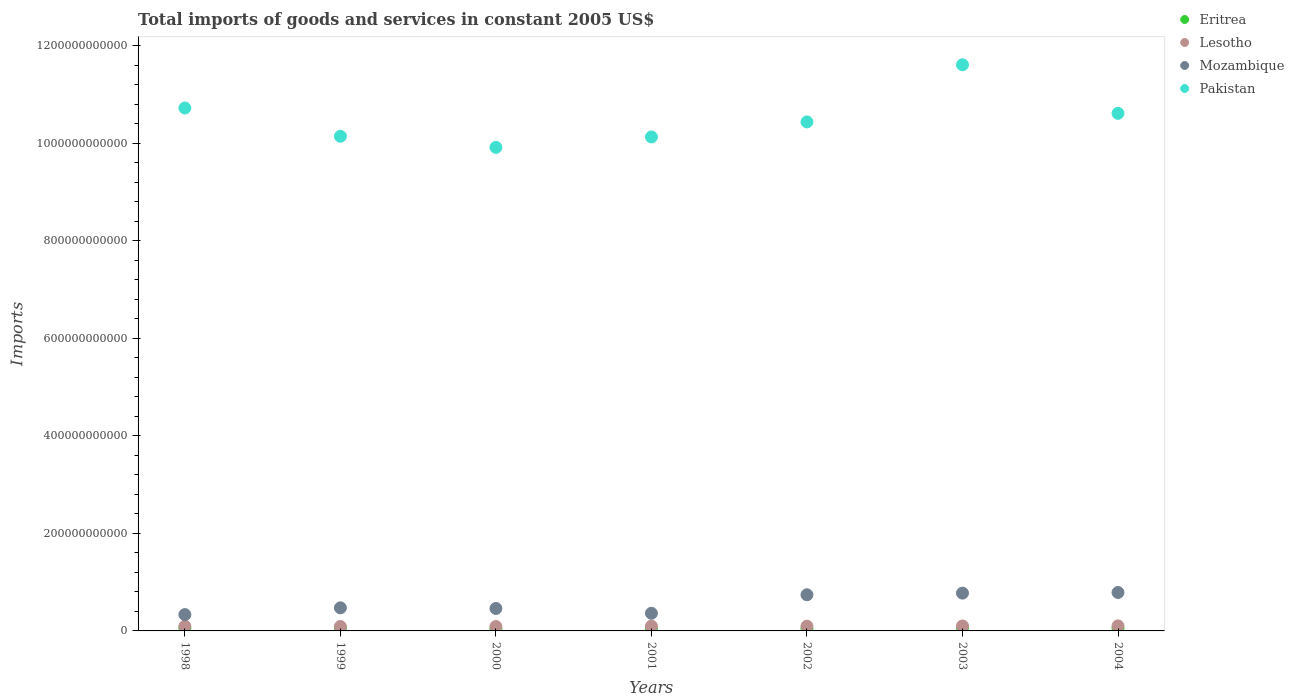Is the number of dotlines equal to the number of legend labels?
Your answer should be compact. Yes. What is the total imports of goods and services in Lesotho in 2004?
Your answer should be very brief. 1.03e+1. Across all years, what is the maximum total imports of goods and services in Eritrea?
Provide a succinct answer. 5.84e+09. Across all years, what is the minimum total imports of goods and services in Eritrea?
Your answer should be very brief. 3.96e+09. What is the total total imports of goods and services in Pakistan in the graph?
Ensure brevity in your answer.  7.36e+12. What is the difference between the total imports of goods and services in Lesotho in 2001 and that in 2002?
Give a very brief answer. 6.00e+07. What is the difference between the total imports of goods and services in Lesotho in 2003 and the total imports of goods and services in Pakistan in 1999?
Provide a short and direct response. -1.00e+12. What is the average total imports of goods and services in Eritrea per year?
Provide a succinct answer. 5.07e+09. In the year 2004, what is the difference between the total imports of goods and services in Eritrea and total imports of goods and services in Lesotho?
Provide a succinct answer. -4.99e+09. What is the ratio of the total imports of goods and services in Mozambique in 2000 to that in 2001?
Your answer should be compact. 1.27. Is the total imports of goods and services in Eritrea in 2002 less than that in 2003?
Ensure brevity in your answer.  Yes. What is the difference between the highest and the second highest total imports of goods and services in Lesotho?
Your response must be concise. 1.52e+08. What is the difference between the highest and the lowest total imports of goods and services in Pakistan?
Give a very brief answer. 1.69e+11. In how many years, is the total imports of goods and services in Lesotho greater than the average total imports of goods and services in Lesotho taken over all years?
Offer a terse response. 4. Is the sum of the total imports of goods and services in Eritrea in 1998 and 2000 greater than the maximum total imports of goods and services in Lesotho across all years?
Ensure brevity in your answer.  No. Is it the case that in every year, the sum of the total imports of goods and services in Mozambique and total imports of goods and services in Pakistan  is greater than the sum of total imports of goods and services in Lesotho and total imports of goods and services in Eritrea?
Your answer should be compact. Yes. Does the total imports of goods and services in Mozambique monotonically increase over the years?
Keep it short and to the point. No. Is the total imports of goods and services in Pakistan strictly greater than the total imports of goods and services in Eritrea over the years?
Keep it short and to the point. Yes. Is the total imports of goods and services in Pakistan strictly less than the total imports of goods and services in Lesotho over the years?
Make the answer very short. No. What is the difference between two consecutive major ticks on the Y-axis?
Offer a very short reply. 2.00e+11. Are the values on the major ticks of Y-axis written in scientific E-notation?
Your response must be concise. No. Where does the legend appear in the graph?
Provide a succinct answer. Top right. How are the legend labels stacked?
Give a very brief answer. Vertical. What is the title of the graph?
Ensure brevity in your answer.  Total imports of goods and services in constant 2005 US$. What is the label or title of the Y-axis?
Provide a short and direct response. Imports. What is the Imports of Eritrea in 1998?
Ensure brevity in your answer.  5.74e+09. What is the Imports in Lesotho in 1998?
Your answer should be very brief. 9.67e+09. What is the Imports of Mozambique in 1998?
Offer a very short reply. 3.35e+1. What is the Imports of Pakistan in 1998?
Offer a terse response. 1.07e+12. What is the Imports of Eritrea in 1999?
Your answer should be very brief. 5.84e+09. What is the Imports in Lesotho in 1999?
Give a very brief answer. 9.06e+09. What is the Imports of Mozambique in 1999?
Your response must be concise. 4.74e+1. What is the Imports of Pakistan in 1999?
Your response must be concise. 1.01e+12. What is the Imports of Eritrea in 2000?
Make the answer very short. 3.96e+09. What is the Imports of Lesotho in 2000?
Your answer should be very brief. 9.07e+09. What is the Imports in Mozambique in 2000?
Ensure brevity in your answer.  4.60e+1. What is the Imports of Pakistan in 2000?
Your answer should be compact. 9.92e+11. What is the Imports in Eritrea in 2001?
Offer a terse response. 4.54e+09. What is the Imports of Lesotho in 2001?
Give a very brief answer. 9.80e+09. What is the Imports in Mozambique in 2001?
Offer a terse response. 3.62e+1. What is the Imports in Pakistan in 2001?
Your answer should be compact. 1.01e+12. What is the Imports of Eritrea in 2002?
Make the answer very short. 4.62e+09. What is the Imports of Lesotho in 2002?
Your answer should be very brief. 9.74e+09. What is the Imports in Mozambique in 2002?
Make the answer very short. 7.41e+1. What is the Imports in Pakistan in 2002?
Make the answer very short. 1.04e+12. What is the Imports in Eritrea in 2003?
Offer a very short reply. 5.43e+09. What is the Imports of Lesotho in 2003?
Keep it short and to the point. 1.02e+1. What is the Imports in Mozambique in 2003?
Ensure brevity in your answer.  7.75e+1. What is the Imports in Pakistan in 2003?
Give a very brief answer. 1.16e+12. What is the Imports in Eritrea in 2004?
Ensure brevity in your answer.  5.35e+09. What is the Imports of Lesotho in 2004?
Ensure brevity in your answer.  1.03e+1. What is the Imports of Mozambique in 2004?
Provide a short and direct response. 7.88e+1. What is the Imports of Pakistan in 2004?
Offer a terse response. 1.06e+12. Across all years, what is the maximum Imports in Eritrea?
Keep it short and to the point. 5.84e+09. Across all years, what is the maximum Imports of Lesotho?
Provide a short and direct response. 1.03e+1. Across all years, what is the maximum Imports of Mozambique?
Provide a succinct answer. 7.88e+1. Across all years, what is the maximum Imports of Pakistan?
Provide a succinct answer. 1.16e+12. Across all years, what is the minimum Imports in Eritrea?
Ensure brevity in your answer.  3.96e+09. Across all years, what is the minimum Imports of Lesotho?
Offer a very short reply. 9.06e+09. Across all years, what is the minimum Imports in Mozambique?
Your answer should be compact. 3.35e+1. Across all years, what is the minimum Imports in Pakistan?
Offer a very short reply. 9.92e+11. What is the total Imports of Eritrea in the graph?
Provide a succinct answer. 3.55e+1. What is the total Imports of Lesotho in the graph?
Offer a terse response. 6.79e+1. What is the total Imports of Mozambique in the graph?
Make the answer very short. 3.94e+11. What is the total Imports in Pakistan in the graph?
Keep it short and to the point. 7.36e+12. What is the difference between the Imports of Eritrea in 1998 and that in 1999?
Your response must be concise. -1.03e+08. What is the difference between the Imports in Lesotho in 1998 and that in 1999?
Provide a short and direct response. 6.06e+08. What is the difference between the Imports of Mozambique in 1998 and that in 1999?
Keep it short and to the point. -1.39e+1. What is the difference between the Imports in Pakistan in 1998 and that in 1999?
Provide a short and direct response. 5.79e+1. What is the difference between the Imports of Eritrea in 1998 and that in 2000?
Make the answer very short. 1.78e+09. What is the difference between the Imports of Lesotho in 1998 and that in 2000?
Keep it short and to the point. 6.01e+08. What is the difference between the Imports in Mozambique in 1998 and that in 2000?
Provide a short and direct response. -1.26e+1. What is the difference between the Imports in Pakistan in 1998 and that in 2000?
Ensure brevity in your answer.  8.08e+1. What is the difference between the Imports in Eritrea in 1998 and that in 2001?
Provide a succinct answer. 1.21e+09. What is the difference between the Imports of Lesotho in 1998 and that in 2001?
Give a very brief answer. -1.25e+08. What is the difference between the Imports of Mozambique in 1998 and that in 2001?
Your response must be concise. -2.75e+09. What is the difference between the Imports of Pakistan in 1998 and that in 2001?
Your answer should be very brief. 5.93e+1. What is the difference between the Imports of Eritrea in 1998 and that in 2002?
Offer a terse response. 1.12e+09. What is the difference between the Imports of Lesotho in 1998 and that in 2002?
Your answer should be very brief. -6.50e+07. What is the difference between the Imports in Mozambique in 1998 and that in 2002?
Keep it short and to the point. -4.07e+1. What is the difference between the Imports of Pakistan in 1998 and that in 2002?
Give a very brief answer. 2.85e+1. What is the difference between the Imports of Eritrea in 1998 and that in 2003?
Ensure brevity in your answer.  3.11e+08. What is the difference between the Imports in Lesotho in 1998 and that in 2003?
Provide a short and direct response. -5.24e+08. What is the difference between the Imports in Mozambique in 1998 and that in 2003?
Your response must be concise. -4.41e+1. What is the difference between the Imports of Pakistan in 1998 and that in 2003?
Offer a terse response. -8.87e+1. What is the difference between the Imports of Eritrea in 1998 and that in 2004?
Your answer should be very brief. 3.86e+08. What is the difference between the Imports in Lesotho in 1998 and that in 2004?
Your response must be concise. -6.76e+08. What is the difference between the Imports in Mozambique in 1998 and that in 2004?
Offer a very short reply. -4.54e+1. What is the difference between the Imports in Pakistan in 1998 and that in 2004?
Make the answer very short. 1.09e+1. What is the difference between the Imports in Eritrea in 1999 and that in 2000?
Your response must be concise. 1.89e+09. What is the difference between the Imports in Lesotho in 1999 and that in 2000?
Your response must be concise. -4.86e+06. What is the difference between the Imports in Mozambique in 1999 and that in 2000?
Your answer should be compact. 1.32e+09. What is the difference between the Imports of Pakistan in 1999 and that in 2000?
Give a very brief answer. 2.28e+1. What is the difference between the Imports of Eritrea in 1999 and that in 2001?
Offer a terse response. 1.31e+09. What is the difference between the Imports of Lesotho in 1999 and that in 2001?
Keep it short and to the point. -7.31e+08. What is the difference between the Imports of Mozambique in 1999 and that in 2001?
Your response must be concise. 1.11e+1. What is the difference between the Imports in Pakistan in 1999 and that in 2001?
Ensure brevity in your answer.  1.41e+09. What is the difference between the Imports in Eritrea in 1999 and that in 2002?
Give a very brief answer. 1.22e+09. What is the difference between the Imports of Lesotho in 1999 and that in 2002?
Your answer should be compact. -6.71e+08. What is the difference between the Imports of Mozambique in 1999 and that in 2002?
Make the answer very short. -2.68e+1. What is the difference between the Imports of Pakistan in 1999 and that in 2002?
Offer a very short reply. -2.94e+1. What is the difference between the Imports in Eritrea in 1999 and that in 2003?
Offer a terse response. 4.14e+08. What is the difference between the Imports of Lesotho in 1999 and that in 2003?
Ensure brevity in your answer.  -1.13e+09. What is the difference between the Imports of Mozambique in 1999 and that in 2003?
Keep it short and to the point. -3.02e+1. What is the difference between the Imports in Pakistan in 1999 and that in 2003?
Give a very brief answer. -1.47e+11. What is the difference between the Imports in Eritrea in 1999 and that in 2004?
Keep it short and to the point. 4.90e+08. What is the difference between the Imports in Lesotho in 1999 and that in 2004?
Provide a short and direct response. -1.28e+09. What is the difference between the Imports in Mozambique in 1999 and that in 2004?
Your answer should be compact. -3.15e+1. What is the difference between the Imports of Pakistan in 1999 and that in 2004?
Your answer should be compact. -4.70e+1. What is the difference between the Imports in Eritrea in 2000 and that in 2001?
Your answer should be compact. -5.78e+08. What is the difference between the Imports in Lesotho in 2000 and that in 2001?
Keep it short and to the point. -7.26e+08. What is the difference between the Imports of Mozambique in 2000 and that in 2001?
Give a very brief answer. 9.81e+09. What is the difference between the Imports of Pakistan in 2000 and that in 2001?
Your answer should be very brief. -2.14e+1. What is the difference between the Imports of Eritrea in 2000 and that in 2002?
Provide a succinct answer. -6.64e+08. What is the difference between the Imports of Lesotho in 2000 and that in 2002?
Offer a very short reply. -6.66e+08. What is the difference between the Imports in Mozambique in 2000 and that in 2002?
Ensure brevity in your answer.  -2.81e+1. What is the difference between the Imports in Pakistan in 2000 and that in 2002?
Give a very brief answer. -5.23e+1. What is the difference between the Imports of Eritrea in 2000 and that in 2003?
Your answer should be compact. -1.47e+09. What is the difference between the Imports in Lesotho in 2000 and that in 2003?
Provide a succinct answer. -1.13e+09. What is the difference between the Imports in Mozambique in 2000 and that in 2003?
Keep it short and to the point. -3.15e+1. What is the difference between the Imports in Pakistan in 2000 and that in 2003?
Keep it short and to the point. -1.69e+11. What is the difference between the Imports in Eritrea in 2000 and that in 2004?
Your answer should be very brief. -1.40e+09. What is the difference between the Imports of Lesotho in 2000 and that in 2004?
Your response must be concise. -1.28e+09. What is the difference between the Imports of Mozambique in 2000 and that in 2004?
Provide a short and direct response. -3.28e+1. What is the difference between the Imports of Pakistan in 2000 and that in 2004?
Offer a very short reply. -6.98e+1. What is the difference between the Imports in Eritrea in 2001 and that in 2002?
Your response must be concise. -8.56e+07. What is the difference between the Imports of Lesotho in 2001 and that in 2002?
Your response must be concise. 6.00e+07. What is the difference between the Imports of Mozambique in 2001 and that in 2002?
Provide a short and direct response. -3.79e+1. What is the difference between the Imports of Pakistan in 2001 and that in 2002?
Offer a very short reply. -3.08e+1. What is the difference between the Imports of Eritrea in 2001 and that in 2003?
Your response must be concise. -8.95e+08. What is the difference between the Imports of Lesotho in 2001 and that in 2003?
Provide a short and direct response. -3.99e+08. What is the difference between the Imports of Mozambique in 2001 and that in 2003?
Ensure brevity in your answer.  -4.13e+1. What is the difference between the Imports of Pakistan in 2001 and that in 2003?
Provide a short and direct response. -1.48e+11. What is the difference between the Imports of Eritrea in 2001 and that in 2004?
Ensure brevity in your answer.  -8.19e+08. What is the difference between the Imports of Lesotho in 2001 and that in 2004?
Give a very brief answer. -5.51e+08. What is the difference between the Imports in Mozambique in 2001 and that in 2004?
Your answer should be compact. -4.26e+1. What is the difference between the Imports of Pakistan in 2001 and that in 2004?
Provide a short and direct response. -4.84e+1. What is the difference between the Imports of Eritrea in 2002 and that in 2003?
Make the answer very short. -8.09e+08. What is the difference between the Imports of Lesotho in 2002 and that in 2003?
Provide a short and direct response. -4.59e+08. What is the difference between the Imports in Mozambique in 2002 and that in 2003?
Offer a terse response. -3.41e+09. What is the difference between the Imports of Pakistan in 2002 and that in 2003?
Offer a terse response. -1.17e+11. What is the difference between the Imports of Eritrea in 2002 and that in 2004?
Your answer should be very brief. -7.33e+08. What is the difference between the Imports of Lesotho in 2002 and that in 2004?
Keep it short and to the point. -6.11e+08. What is the difference between the Imports of Mozambique in 2002 and that in 2004?
Your response must be concise. -4.72e+09. What is the difference between the Imports in Pakistan in 2002 and that in 2004?
Ensure brevity in your answer.  -1.76e+1. What is the difference between the Imports in Eritrea in 2003 and that in 2004?
Keep it short and to the point. 7.59e+07. What is the difference between the Imports of Lesotho in 2003 and that in 2004?
Make the answer very short. -1.52e+08. What is the difference between the Imports of Mozambique in 2003 and that in 2004?
Provide a short and direct response. -1.30e+09. What is the difference between the Imports in Pakistan in 2003 and that in 2004?
Offer a very short reply. 9.96e+1. What is the difference between the Imports of Eritrea in 1998 and the Imports of Lesotho in 1999?
Keep it short and to the point. -3.32e+09. What is the difference between the Imports in Eritrea in 1998 and the Imports in Mozambique in 1999?
Provide a succinct answer. -4.16e+1. What is the difference between the Imports in Eritrea in 1998 and the Imports in Pakistan in 1999?
Ensure brevity in your answer.  -1.01e+12. What is the difference between the Imports in Lesotho in 1998 and the Imports in Mozambique in 1999?
Make the answer very short. -3.77e+1. What is the difference between the Imports in Lesotho in 1998 and the Imports in Pakistan in 1999?
Provide a succinct answer. -1.01e+12. What is the difference between the Imports in Mozambique in 1998 and the Imports in Pakistan in 1999?
Ensure brevity in your answer.  -9.81e+11. What is the difference between the Imports of Eritrea in 1998 and the Imports of Lesotho in 2000?
Your response must be concise. -3.33e+09. What is the difference between the Imports in Eritrea in 1998 and the Imports in Mozambique in 2000?
Make the answer very short. -4.03e+1. What is the difference between the Imports in Eritrea in 1998 and the Imports in Pakistan in 2000?
Ensure brevity in your answer.  -9.86e+11. What is the difference between the Imports in Lesotho in 1998 and the Imports in Mozambique in 2000?
Your answer should be compact. -3.64e+1. What is the difference between the Imports of Lesotho in 1998 and the Imports of Pakistan in 2000?
Your answer should be very brief. -9.82e+11. What is the difference between the Imports of Mozambique in 1998 and the Imports of Pakistan in 2000?
Your answer should be compact. -9.58e+11. What is the difference between the Imports in Eritrea in 1998 and the Imports in Lesotho in 2001?
Give a very brief answer. -4.05e+09. What is the difference between the Imports of Eritrea in 1998 and the Imports of Mozambique in 2001?
Ensure brevity in your answer.  -3.05e+1. What is the difference between the Imports in Eritrea in 1998 and the Imports in Pakistan in 2001?
Keep it short and to the point. -1.01e+12. What is the difference between the Imports of Lesotho in 1998 and the Imports of Mozambique in 2001?
Ensure brevity in your answer.  -2.66e+1. What is the difference between the Imports of Lesotho in 1998 and the Imports of Pakistan in 2001?
Your response must be concise. -1.00e+12. What is the difference between the Imports of Mozambique in 1998 and the Imports of Pakistan in 2001?
Provide a short and direct response. -9.80e+11. What is the difference between the Imports of Eritrea in 1998 and the Imports of Lesotho in 2002?
Offer a very short reply. -3.99e+09. What is the difference between the Imports of Eritrea in 1998 and the Imports of Mozambique in 2002?
Your response must be concise. -6.84e+1. What is the difference between the Imports in Eritrea in 1998 and the Imports in Pakistan in 2002?
Give a very brief answer. -1.04e+12. What is the difference between the Imports in Lesotho in 1998 and the Imports in Mozambique in 2002?
Offer a terse response. -6.45e+1. What is the difference between the Imports in Lesotho in 1998 and the Imports in Pakistan in 2002?
Offer a terse response. -1.03e+12. What is the difference between the Imports of Mozambique in 1998 and the Imports of Pakistan in 2002?
Ensure brevity in your answer.  -1.01e+12. What is the difference between the Imports in Eritrea in 1998 and the Imports in Lesotho in 2003?
Give a very brief answer. -4.45e+09. What is the difference between the Imports of Eritrea in 1998 and the Imports of Mozambique in 2003?
Your response must be concise. -7.18e+1. What is the difference between the Imports in Eritrea in 1998 and the Imports in Pakistan in 2003?
Give a very brief answer. -1.16e+12. What is the difference between the Imports in Lesotho in 1998 and the Imports in Mozambique in 2003?
Offer a terse response. -6.79e+1. What is the difference between the Imports in Lesotho in 1998 and the Imports in Pakistan in 2003?
Keep it short and to the point. -1.15e+12. What is the difference between the Imports of Mozambique in 1998 and the Imports of Pakistan in 2003?
Your answer should be compact. -1.13e+12. What is the difference between the Imports of Eritrea in 1998 and the Imports of Lesotho in 2004?
Provide a short and direct response. -4.61e+09. What is the difference between the Imports in Eritrea in 1998 and the Imports in Mozambique in 2004?
Your answer should be compact. -7.31e+1. What is the difference between the Imports in Eritrea in 1998 and the Imports in Pakistan in 2004?
Ensure brevity in your answer.  -1.06e+12. What is the difference between the Imports of Lesotho in 1998 and the Imports of Mozambique in 2004?
Keep it short and to the point. -6.92e+1. What is the difference between the Imports in Lesotho in 1998 and the Imports in Pakistan in 2004?
Your answer should be compact. -1.05e+12. What is the difference between the Imports of Mozambique in 1998 and the Imports of Pakistan in 2004?
Give a very brief answer. -1.03e+12. What is the difference between the Imports in Eritrea in 1999 and the Imports in Lesotho in 2000?
Provide a short and direct response. -3.23e+09. What is the difference between the Imports in Eritrea in 1999 and the Imports in Mozambique in 2000?
Ensure brevity in your answer.  -4.02e+1. What is the difference between the Imports in Eritrea in 1999 and the Imports in Pakistan in 2000?
Provide a succinct answer. -9.86e+11. What is the difference between the Imports of Lesotho in 1999 and the Imports of Mozambique in 2000?
Offer a very short reply. -3.70e+1. What is the difference between the Imports in Lesotho in 1999 and the Imports in Pakistan in 2000?
Your answer should be compact. -9.83e+11. What is the difference between the Imports in Mozambique in 1999 and the Imports in Pakistan in 2000?
Provide a short and direct response. -9.45e+11. What is the difference between the Imports of Eritrea in 1999 and the Imports of Lesotho in 2001?
Provide a short and direct response. -3.95e+09. What is the difference between the Imports in Eritrea in 1999 and the Imports in Mozambique in 2001?
Your answer should be very brief. -3.04e+1. What is the difference between the Imports of Eritrea in 1999 and the Imports of Pakistan in 2001?
Your response must be concise. -1.01e+12. What is the difference between the Imports of Lesotho in 1999 and the Imports of Mozambique in 2001?
Your response must be concise. -2.72e+1. What is the difference between the Imports in Lesotho in 1999 and the Imports in Pakistan in 2001?
Ensure brevity in your answer.  -1.00e+12. What is the difference between the Imports of Mozambique in 1999 and the Imports of Pakistan in 2001?
Ensure brevity in your answer.  -9.66e+11. What is the difference between the Imports of Eritrea in 1999 and the Imports of Lesotho in 2002?
Your answer should be compact. -3.89e+09. What is the difference between the Imports of Eritrea in 1999 and the Imports of Mozambique in 2002?
Your answer should be compact. -6.83e+1. What is the difference between the Imports of Eritrea in 1999 and the Imports of Pakistan in 2002?
Your answer should be very brief. -1.04e+12. What is the difference between the Imports in Lesotho in 1999 and the Imports in Mozambique in 2002?
Offer a very short reply. -6.51e+1. What is the difference between the Imports of Lesotho in 1999 and the Imports of Pakistan in 2002?
Keep it short and to the point. -1.04e+12. What is the difference between the Imports in Mozambique in 1999 and the Imports in Pakistan in 2002?
Provide a short and direct response. -9.97e+11. What is the difference between the Imports in Eritrea in 1999 and the Imports in Lesotho in 2003?
Provide a short and direct response. -4.35e+09. What is the difference between the Imports in Eritrea in 1999 and the Imports in Mozambique in 2003?
Your response must be concise. -7.17e+1. What is the difference between the Imports in Eritrea in 1999 and the Imports in Pakistan in 2003?
Ensure brevity in your answer.  -1.16e+12. What is the difference between the Imports of Lesotho in 1999 and the Imports of Mozambique in 2003?
Your answer should be very brief. -6.85e+1. What is the difference between the Imports of Lesotho in 1999 and the Imports of Pakistan in 2003?
Ensure brevity in your answer.  -1.15e+12. What is the difference between the Imports of Mozambique in 1999 and the Imports of Pakistan in 2003?
Make the answer very short. -1.11e+12. What is the difference between the Imports in Eritrea in 1999 and the Imports in Lesotho in 2004?
Ensure brevity in your answer.  -4.50e+09. What is the difference between the Imports of Eritrea in 1999 and the Imports of Mozambique in 2004?
Your response must be concise. -7.30e+1. What is the difference between the Imports in Eritrea in 1999 and the Imports in Pakistan in 2004?
Provide a succinct answer. -1.06e+12. What is the difference between the Imports in Lesotho in 1999 and the Imports in Mozambique in 2004?
Provide a succinct answer. -6.98e+1. What is the difference between the Imports in Lesotho in 1999 and the Imports in Pakistan in 2004?
Your answer should be very brief. -1.05e+12. What is the difference between the Imports in Mozambique in 1999 and the Imports in Pakistan in 2004?
Make the answer very short. -1.01e+12. What is the difference between the Imports in Eritrea in 2000 and the Imports in Lesotho in 2001?
Offer a very short reply. -5.84e+09. What is the difference between the Imports in Eritrea in 2000 and the Imports in Mozambique in 2001?
Your response must be concise. -3.23e+1. What is the difference between the Imports in Eritrea in 2000 and the Imports in Pakistan in 2001?
Offer a very short reply. -1.01e+12. What is the difference between the Imports in Lesotho in 2000 and the Imports in Mozambique in 2001?
Provide a succinct answer. -2.72e+1. What is the difference between the Imports in Lesotho in 2000 and the Imports in Pakistan in 2001?
Provide a short and direct response. -1.00e+12. What is the difference between the Imports of Mozambique in 2000 and the Imports of Pakistan in 2001?
Make the answer very short. -9.67e+11. What is the difference between the Imports of Eritrea in 2000 and the Imports of Lesotho in 2002?
Make the answer very short. -5.78e+09. What is the difference between the Imports of Eritrea in 2000 and the Imports of Mozambique in 2002?
Offer a very short reply. -7.02e+1. What is the difference between the Imports in Eritrea in 2000 and the Imports in Pakistan in 2002?
Offer a terse response. -1.04e+12. What is the difference between the Imports of Lesotho in 2000 and the Imports of Mozambique in 2002?
Provide a succinct answer. -6.51e+1. What is the difference between the Imports in Lesotho in 2000 and the Imports in Pakistan in 2002?
Provide a succinct answer. -1.04e+12. What is the difference between the Imports of Mozambique in 2000 and the Imports of Pakistan in 2002?
Your response must be concise. -9.98e+11. What is the difference between the Imports in Eritrea in 2000 and the Imports in Lesotho in 2003?
Keep it short and to the point. -6.24e+09. What is the difference between the Imports in Eritrea in 2000 and the Imports in Mozambique in 2003?
Your answer should be compact. -7.36e+1. What is the difference between the Imports of Eritrea in 2000 and the Imports of Pakistan in 2003?
Give a very brief answer. -1.16e+12. What is the difference between the Imports of Lesotho in 2000 and the Imports of Mozambique in 2003?
Your answer should be compact. -6.85e+1. What is the difference between the Imports of Lesotho in 2000 and the Imports of Pakistan in 2003?
Your answer should be compact. -1.15e+12. What is the difference between the Imports of Mozambique in 2000 and the Imports of Pakistan in 2003?
Offer a terse response. -1.12e+12. What is the difference between the Imports in Eritrea in 2000 and the Imports in Lesotho in 2004?
Make the answer very short. -6.39e+09. What is the difference between the Imports in Eritrea in 2000 and the Imports in Mozambique in 2004?
Make the answer very short. -7.49e+1. What is the difference between the Imports in Eritrea in 2000 and the Imports in Pakistan in 2004?
Your answer should be very brief. -1.06e+12. What is the difference between the Imports in Lesotho in 2000 and the Imports in Mozambique in 2004?
Your answer should be very brief. -6.98e+1. What is the difference between the Imports in Lesotho in 2000 and the Imports in Pakistan in 2004?
Make the answer very short. -1.05e+12. What is the difference between the Imports in Mozambique in 2000 and the Imports in Pakistan in 2004?
Your answer should be compact. -1.02e+12. What is the difference between the Imports of Eritrea in 2001 and the Imports of Lesotho in 2002?
Offer a very short reply. -5.20e+09. What is the difference between the Imports of Eritrea in 2001 and the Imports of Mozambique in 2002?
Make the answer very short. -6.96e+1. What is the difference between the Imports of Eritrea in 2001 and the Imports of Pakistan in 2002?
Make the answer very short. -1.04e+12. What is the difference between the Imports in Lesotho in 2001 and the Imports in Mozambique in 2002?
Your answer should be very brief. -6.43e+1. What is the difference between the Imports in Lesotho in 2001 and the Imports in Pakistan in 2002?
Give a very brief answer. -1.03e+12. What is the difference between the Imports in Mozambique in 2001 and the Imports in Pakistan in 2002?
Provide a short and direct response. -1.01e+12. What is the difference between the Imports in Eritrea in 2001 and the Imports in Lesotho in 2003?
Your answer should be compact. -5.66e+09. What is the difference between the Imports in Eritrea in 2001 and the Imports in Mozambique in 2003?
Offer a very short reply. -7.30e+1. What is the difference between the Imports of Eritrea in 2001 and the Imports of Pakistan in 2003?
Your response must be concise. -1.16e+12. What is the difference between the Imports in Lesotho in 2001 and the Imports in Mozambique in 2003?
Offer a terse response. -6.77e+1. What is the difference between the Imports of Lesotho in 2001 and the Imports of Pakistan in 2003?
Offer a terse response. -1.15e+12. What is the difference between the Imports of Mozambique in 2001 and the Imports of Pakistan in 2003?
Keep it short and to the point. -1.13e+12. What is the difference between the Imports of Eritrea in 2001 and the Imports of Lesotho in 2004?
Offer a very short reply. -5.81e+09. What is the difference between the Imports in Eritrea in 2001 and the Imports in Mozambique in 2004?
Your answer should be compact. -7.43e+1. What is the difference between the Imports in Eritrea in 2001 and the Imports in Pakistan in 2004?
Your response must be concise. -1.06e+12. What is the difference between the Imports in Lesotho in 2001 and the Imports in Mozambique in 2004?
Give a very brief answer. -6.91e+1. What is the difference between the Imports of Lesotho in 2001 and the Imports of Pakistan in 2004?
Your answer should be very brief. -1.05e+12. What is the difference between the Imports of Mozambique in 2001 and the Imports of Pakistan in 2004?
Provide a succinct answer. -1.03e+12. What is the difference between the Imports in Eritrea in 2002 and the Imports in Lesotho in 2003?
Give a very brief answer. -5.57e+09. What is the difference between the Imports of Eritrea in 2002 and the Imports of Mozambique in 2003?
Provide a succinct answer. -7.29e+1. What is the difference between the Imports in Eritrea in 2002 and the Imports in Pakistan in 2003?
Offer a very short reply. -1.16e+12. What is the difference between the Imports of Lesotho in 2002 and the Imports of Mozambique in 2003?
Provide a succinct answer. -6.78e+1. What is the difference between the Imports of Lesotho in 2002 and the Imports of Pakistan in 2003?
Offer a very short reply. -1.15e+12. What is the difference between the Imports of Mozambique in 2002 and the Imports of Pakistan in 2003?
Provide a short and direct response. -1.09e+12. What is the difference between the Imports in Eritrea in 2002 and the Imports in Lesotho in 2004?
Your answer should be compact. -5.73e+09. What is the difference between the Imports in Eritrea in 2002 and the Imports in Mozambique in 2004?
Offer a very short reply. -7.42e+1. What is the difference between the Imports of Eritrea in 2002 and the Imports of Pakistan in 2004?
Offer a terse response. -1.06e+12. What is the difference between the Imports of Lesotho in 2002 and the Imports of Mozambique in 2004?
Ensure brevity in your answer.  -6.91e+1. What is the difference between the Imports of Lesotho in 2002 and the Imports of Pakistan in 2004?
Provide a succinct answer. -1.05e+12. What is the difference between the Imports of Mozambique in 2002 and the Imports of Pakistan in 2004?
Your response must be concise. -9.88e+11. What is the difference between the Imports in Eritrea in 2003 and the Imports in Lesotho in 2004?
Make the answer very short. -4.92e+09. What is the difference between the Imports in Eritrea in 2003 and the Imports in Mozambique in 2004?
Provide a succinct answer. -7.34e+1. What is the difference between the Imports of Eritrea in 2003 and the Imports of Pakistan in 2004?
Your response must be concise. -1.06e+12. What is the difference between the Imports in Lesotho in 2003 and the Imports in Mozambique in 2004?
Make the answer very short. -6.87e+1. What is the difference between the Imports in Lesotho in 2003 and the Imports in Pakistan in 2004?
Give a very brief answer. -1.05e+12. What is the difference between the Imports of Mozambique in 2003 and the Imports of Pakistan in 2004?
Offer a very short reply. -9.84e+11. What is the average Imports in Eritrea per year?
Provide a short and direct response. 5.07e+09. What is the average Imports of Lesotho per year?
Your response must be concise. 9.70e+09. What is the average Imports of Mozambique per year?
Your response must be concise. 5.62e+1. What is the average Imports of Pakistan per year?
Your response must be concise. 1.05e+12. In the year 1998, what is the difference between the Imports in Eritrea and Imports in Lesotho?
Keep it short and to the point. -3.93e+09. In the year 1998, what is the difference between the Imports of Eritrea and Imports of Mozambique?
Your answer should be very brief. -2.77e+1. In the year 1998, what is the difference between the Imports of Eritrea and Imports of Pakistan?
Offer a terse response. -1.07e+12. In the year 1998, what is the difference between the Imports of Lesotho and Imports of Mozambique?
Offer a terse response. -2.38e+1. In the year 1998, what is the difference between the Imports in Lesotho and Imports in Pakistan?
Offer a terse response. -1.06e+12. In the year 1998, what is the difference between the Imports of Mozambique and Imports of Pakistan?
Offer a very short reply. -1.04e+12. In the year 1999, what is the difference between the Imports in Eritrea and Imports in Lesotho?
Give a very brief answer. -3.22e+09. In the year 1999, what is the difference between the Imports of Eritrea and Imports of Mozambique?
Provide a short and direct response. -4.15e+1. In the year 1999, what is the difference between the Imports of Eritrea and Imports of Pakistan?
Make the answer very short. -1.01e+12. In the year 1999, what is the difference between the Imports in Lesotho and Imports in Mozambique?
Offer a very short reply. -3.83e+1. In the year 1999, what is the difference between the Imports in Lesotho and Imports in Pakistan?
Ensure brevity in your answer.  -1.01e+12. In the year 1999, what is the difference between the Imports of Mozambique and Imports of Pakistan?
Your response must be concise. -9.67e+11. In the year 2000, what is the difference between the Imports in Eritrea and Imports in Lesotho?
Make the answer very short. -5.11e+09. In the year 2000, what is the difference between the Imports of Eritrea and Imports of Mozambique?
Keep it short and to the point. -4.21e+1. In the year 2000, what is the difference between the Imports in Eritrea and Imports in Pakistan?
Make the answer very short. -9.88e+11. In the year 2000, what is the difference between the Imports of Lesotho and Imports of Mozambique?
Offer a terse response. -3.70e+1. In the year 2000, what is the difference between the Imports in Lesotho and Imports in Pakistan?
Your answer should be very brief. -9.83e+11. In the year 2000, what is the difference between the Imports of Mozambique and Imports of Pakistan?
Provide a short and direct response. -9.46e+11. In the year 2001, what is the difference between the Imports of Eritrea and Imports of Lesotho?
Your answer should be compact. -5.26e+09. In the year 2001, what is the difference between the Imports of Eritrea and Imports of Mozambique?
Make the answer very short. -3.17e+1. In the year 2001, what is the difference between the Imports of Eritrea and Imports of Pakistan?
Ensure brevity in your answer.  -1.01e+12. In the year 2001, what is the difference between the Imports of Lesotho and Imports of Mozambique?
Make the answer very short. -2.64e+1. In the year 2001, what is the difference between the Imports in Lesotho and Imports in Pakistan?
Provide a short and direct response. -1.00e+12. In the year 2001, what is the difference between the Imports of Mozambique and Imports of Pakistan?
Provide a short and direct response. -9.77e+11. In the year 2002, what is the difference between the Imports of Eritrea and Imports of Lesotho?
Your answer should be compact. -5.11e+09. In the year 2002, what is the difference between the Imports of Eritrea and Imports of Mozambique?
Make the answer very short. -6.95e+1. In the year 2002, what is the difference between the Imports in Eritrea and Imports in Pakistan?
Offer a very short reply. -1.04e+12. In the year 2002, what is the difference between the Imports in Lesotho and Imports in Mozambique?
Keep it short and to the point. -6.44e+1. In the year 2002, what is the difference between the Imports in Lesotho and Imports in Pakistan?
Provide a short and direct response. -1.03e+12. In the year 2002, what is the difference between the Imports of Mozambique and Imports of Pakistan?
Keep it short and to the point. -9.70e+11. In the year 2003, what is the difference between the Imports of Eritrea and Imports of Lesotho?
Your response must be concise. -4.76e+09. In the year 2003, what is the difference between the Imports of Eritrea and Imports of Mozambique?
Make the answer very short. -7.21e+1. In the year 2003, what is the difference between the Imports of Eritrea and Imports of Pakistan?
Offer a very short reply. -1.16e+12. In the year 2003, what is the difference between the Imports of Lesotho and Imports of Mozambique?
Provide a succinct answer. -6.73e+1. In the year 2003, what is the difference between the Imports of Lesotho and Imports of Pakistan?
Your answer should be compact. -1.15e+12. In the year 2003, what is the difference between the Imports in Mozambique and Imports in Pakistan?
Keep it short and to the point. -1.08e+12. In the year 2004, what is the difference between the Imports in Eritrea and Imports in Lesotho?
Provide a succinct answer. -4.99e+09. In the year 2004, what is the difference between the Imports in Eritrea and Imports in Mozambique?
Offer a very short reply. -7.35e+1. In the year 2004, what is the difference between the Imports in Eritrea and Imports in Pakistan?
Ensure brevity in your answer.  -1.06e+12. In the year 2004, what is the difference between the Imports in Lesotho and Imports in Mozambique?
Ensure brevity in your answer.  -6.85e+1. In the year 2004, what is the difference between the Imports of Lesotho and Imports of Pakistan?
Give a very brief answer. -1.05e+12. In the year 2004, what is the difference between the Imports in Mozambique and Imports in Pakistan?
Your answer should be very brief. -9.83e+11. What is the ratio of the Imports of Eritrea in 1998 to that in 1999?
Your response must be concise. 0.98. What is the ratio of the Imports of Lesotho in 1998 to that in 1999?
Your answer should be very brief. 1.07. What is the ratio of the Imports of Mozambique in 1998 to that in 1999?
Your answer should be compact. 0.71. What is the ratio of the Imports in Pakistan in 1998 to that in 1999?
Make the answer very short. 1.06. What is the ratio of the Imports of Eritrea in 1998 to that in 2000?
Offer a terse response. 1.45. What is the ratio of the Imports in Lesotho in 1998 to that in 2000?
Your response must be concise. 1.07. What is the ratio of the Imports in Mozambique in 1998 to that in 2000?
Provide a succinct answer. 0.73. What is the ratio of the Imports in Pakistan in 1998 to that in 2000?
Your answer should be compact. 1.08. What is the ratio of the Imports of Eritrea in 1998 to that in 2001?
Offer a very short reply. 1.27. What is the ratio of the Imports in Lesotho in 1998 to that in 2001?
Ensure brevity in your answer.  0.99. What is the ratio of the Imports of Mozambique in 1998 to that in 2001?
Provide a succinct answer. 0.92. What is the ratio of the Imports of Pakistan in 1998 to that in 2001?
Your answer should be compact. 1.06. What is the ratio of the Imports of Eritrea in 1998 to that in 2002?
Provide a succinct answer. 1.24. What is the ratio of the Imports in Lesotho in 1998 to that in 2002?
Your answer should be very brief. 0.99. What is the ratio of the Imports of Mozambique in 1998 to that in 2002?
Ensure brevity in your answer.  0.45. What is the ratio of the Imports in Pakistan in 1998 to that in 2002?
Offer a very short reply. 1.03. What is the ratio of the Imports of Eritrea in 1998 to that in 2003?
Your answer should be compact. 1.06. What is the ratio of the Imports of Lesotho in 1998 to that in 2003?
Give a very brief answer. 0.95. What is the ratio of the Imports in Mozambique in 1998 to that in 2003?
Your answer should be compact. 0.43. What is the ratio of the Imports of Pakistan in 1998 to that in 2003?
Give a very brief answer. 0.92. What is the ratio of the Imports of Eritrea in 1998 to that in 2004?
Offer a very short reply. 1.07. What is the ratio of the Imports in Lesotho in 1998 to that in 2004?
Give a very brief answer. 0.93. What is the ratio of the Imports in Mozambique in 1998 to that in 2004?
Your answer should be compact. 0.42. What is the ratio of the Imports in Pakistan in 1998 to that in 2004?
Your response must be concise. 1.01. What is the ratio of the Imports of Eritrea in 1999 to that in 2000?
Provide a succinct answer. 1.48. What is the ratio of the Imports in Mozambique in 1999 to that in 2000?
Provide a succinct answer. 1.03. What is the ratio of the Imports in Pakistan in 1999 to that in 2000?
Ensure brevity in your answer.  1.02. What is the ratio of the Imports of Eritrea in 1999 to that in 2001?
Offer a terse response. 1.29. What is the ratio of the Imports in Lesotho in 1999 to that in 2001?
Make the answer very short. 0.93. What is the ratio of the Imports of Mozambique in 1999 to that in 2001?
Ensure brevity in your answer.  1.31. What is the ratio of the Imports of Pakistan in 1999 to that in 2001?
Make the answer very short. 1. What is the ratio of the Imports of Eritrea in 1999 to that in 2002?
Make the answer very short. 1.26. What is the ratio of the Imports in Lesotho in 1999 to that in 2002?
Provide a short and direct response. 0.93. What is the ratio of the Imports of Mozambique in 1999 to that in 2002?
Offer a very short reply. 0.64. What is the ratio of the Imports of Pakistan in 1999 to that in 2002?
Make the answer very short. 0.97. What is the ratio of the Imports of Eritrea in 1999 to that in 2003?
Provide a short and direct response. 1.08. What is the ratio of the Imports of Lesotho in 1999 to that in 2003?
Give a very brief answer. 0.89. What is the ratio of the Imports in Mozambique in 1999 to that in 2003?
Your answer should be compact. 0.61. What is the ratio of the Imports of Pakistan in 1999 to that in 2003?
Give a very brief answer. 0.87. What is the ratio of the Imports of Eritrea in 1999 to that in 2004?
Provide a short and direct response. 1.09. What is the ratio of the Imports in Lesotho in 1999 to that in 2004?
Your response must be concise. 0.88. What is the ratio of the Imports of Mozambique in 1999 to that in 2004?
Your answer should be compact. 0.6. What is the ratio of the Imports of Pakistan in 1999 to that in 2004?
Offer a terse response. 0.96. What is the ratio of the Imports in Eritrea in 2000 to that in 2001?
Give a very brief answer. 0.87. What is the ratio of the Imports of Lesotho in 2000 to that in 2001?
Provide a short and direct response. 0.93. What is the ratio of the Imports in Mozambique in 2000 to that in 2001?
Your answer should be compact. 1.27. What is the ratio of the Imports of Pakistan in 2000 to that in 2001?
Offer a terse response. 0.98. What is the ratio of the Imports of Eritrea in 2000 to that in 2002?
Offer a terse response. 0.86. What is the ratio of the Imports of Lesotho in 2000 to that in 2002?
Your response must be concise. 0.93. What is the ratio of the Imports of Mozambique in 2000 to that in 2002?
Make the answer very short. 0.62. What is the ratio of the Imports of Pakistan in 2000 to that in 2002?
Make the answer very short. 0.95. What is the ratio of the Imports of Eritrea in 2000 to that in 2003?
Keep it short and to the point. 0.73. What is the ratio of the Imports in Lesotho in 2000 to that in 2003?
Offer a terse response. 0.89. What is the ratio of the Imports of Mozambique in 2000 to that in 2003?
Keep it short and to the point. 0.59. What is the ratio of the Imports of Pakistan in 2000 to that in 2003?
Offer a very short reply. 0.85. What is the ratio of the Imports in Eritrea in 2000 to that in 2004?
Ensure brevity in your answer.  0.74. What is the ratio of the Imports of Lesotho in 2000 to that in 2004?
Keep it short and to the point. 0.88. What is the ratio of the Imports of Mozambique in 2000 to that in 2004?
Your response must be concise. 0.58. What is the ratio of the Imports of Pakistan in 2000 to that in 2004?
Give a very brief answer. 0.93. What is the ratio of the Imports of Eritrea in 2001 to that in 2002?
Your answer should be compact. 0.98. What is the ratio of the Imports of Mozambique in 2001 to that in 2002?
Your answer should be very brief. 0.49. What is the ratio of the Imports in Pakistan in 2001 to that in 2002?
Make the answer very short. 0.97. What is the ratio of the Imports in Eritrea in 2001 to that in 2003?
Keep it short and to the point. 0.84. What is the ratio of the Imports in Lesotho in 2001 to that in 2003?
Your answer should be very brief. 0.96. What is the ratio of the Imports of Mozambique in 2001 to that in 2003?
Ensure brevity in your answer.  0.47. What is the ratio of the Imports in Pakistan in 2001 to that in 2003?
Your answer should be very brief. 0.87. What is the ratio of the Imports in Eritrea in 2001 to that in 2004?
Offer a terse response. 0.85. What is the ratio of the Imports of Lesotho in 2001 to that in 2004?
Keep it short and to the point. 0.95. What is the ratio of the Imports of Mozambique in 2001 to that in 2004?
Keep it short and to the point. 0.46. What is the ratio of the Imports of Pakistan in 2001 to that in 2004?
Your response must be concise. 0.95. What is the ratio of the Imports of Eritrea in 2002 to that in 2003?
Provide a succinct answer. 0.85. What is the ratio of the Imports of Lesotho in 2002 to that in 2003?
Give a very brief answer. 0.95. What is the ratio of the Imports in Mozambique in 2002 to that in 2003?
Your answer should be very brief. 0.96. What is the ratio of the Imports in Pakistan in 2002 to that in 2003?
Your answer should be compact. 0.9. What is the ratio of the Imports in Eritrea in 2002 to that in 2004?
Your answer should be compact. 0.86. What is the ratio of the Imports of Lesotho in 2002 to that in 2004?
Offer a very short reply. 0.94. What is the ratio of the Imports in Mozambique in 2002 to that in 2004?
Ensure brevity in your answer.  0.94. What is the ratio of the Imports in Pakistan in 2002 to that in 2004?
Ensure brevity in your answer.  0.98. What is the ratio of the Imports in Eritrea in 2003 to that in 2004?
Ensure brevity in your answer.  1.01. What is the ratio of the Imports of Mozambique in 2003 to that in 2004?
Offer a terse response. 0.98. What is the ratio of the Imports in Pakistan in 2003 to that in 2004?
Make the answer very short. 1.09. What is the difference between the highest and the second highest Imports in Eritrea?
Provide a short and direct response. 1.03e+08. What is the difference between the highest and the second highest Imports in Lesotho?
Provide a succinct answer. 1.52e+08. What is the difference between the highest and the second highest Imports in Mozambique?
Keep it short and to the point. 1.30e+09. What is the difference between the highest and the second highest Imports of Pakistan?
Provide a short and direct response. 8.87e+1. What is the difference between the highest and the lowest Imports in Eritrea?
Give a very brief answer. 1.89e+09. What is the difference between the highest and the lowest Imports of Lesotho?
Your answer should be compact. 1.28e+09. What is the difference between the highest and the lowest Imports in Mozambique?
Offer a very short reply. 4.54e+1. What is the difference between the highest and the lowest Imports of Pakistan?
Provide a short and direct response. 1.69e+11. 